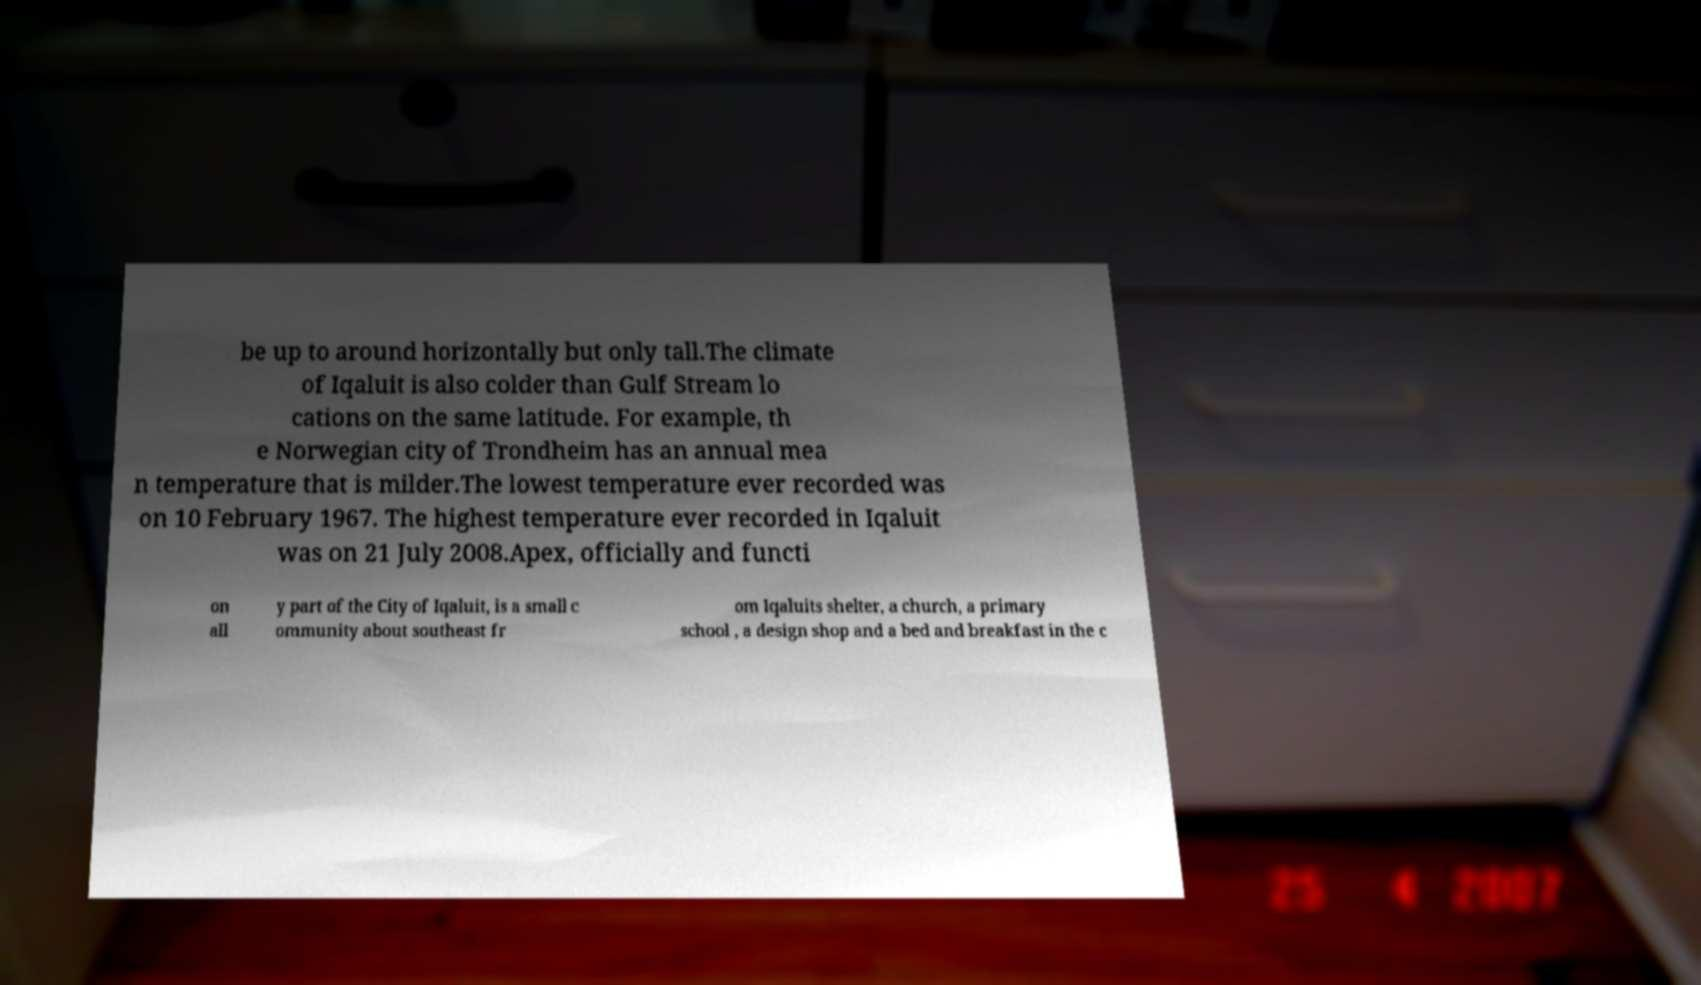I need the written content from this picture converted into text. Can you do that? be up to around horizontally but only tall.The climate of Iqaluit is also colder than Gulf Stream lo cations on the same latitude. For example, th e Norwegian city of Trondheim has an annual mea n temperature that is milder.The lowest temperature ever recorded was on 10 February 1967. The highest temperature ever recorded in Iqaluit was on 21 July 2008.Apex, officially and functi on all y part of the City of Iqaluit, is a small c ommunity about southeast fr om Iqaluits shelter, a church, a primary school , a design shop and a bed and breakfast in the c 